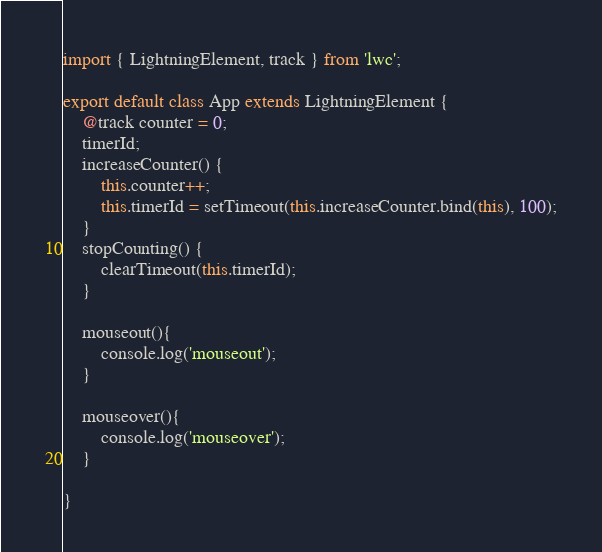Convert code to text. <code><loc_0><loc_0><loc_500><loc_500><_JavaScript_>import { LightningElement, track } from 'lwc';

export default class App extends LightningElement {
    @track counter = 0;
    timerId;
    increaseCounter() {
        this.counter++;
        this.timerId = setTimeout(this.increaseCounter.bind(this), 100);
    }
    stopCounting() {
        clearTimeout(this.timerId);
    }

    mouseout(){
        console.log('mouseout');
    }

    mouseover(){
        console.log('mouseover');
    }

}</code> 